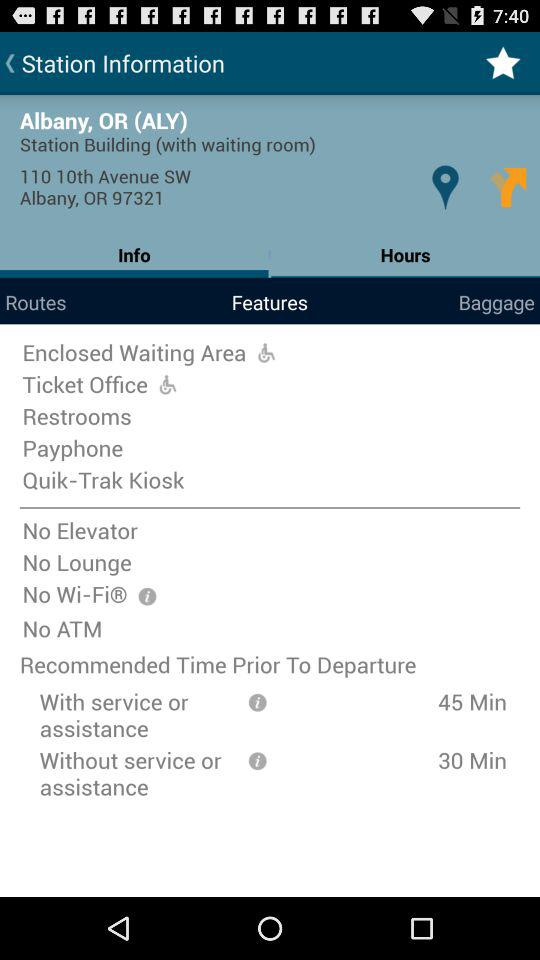What is the address of the station? The address of the station is 110 10th Avenue SW, Albany, OR 97321. 